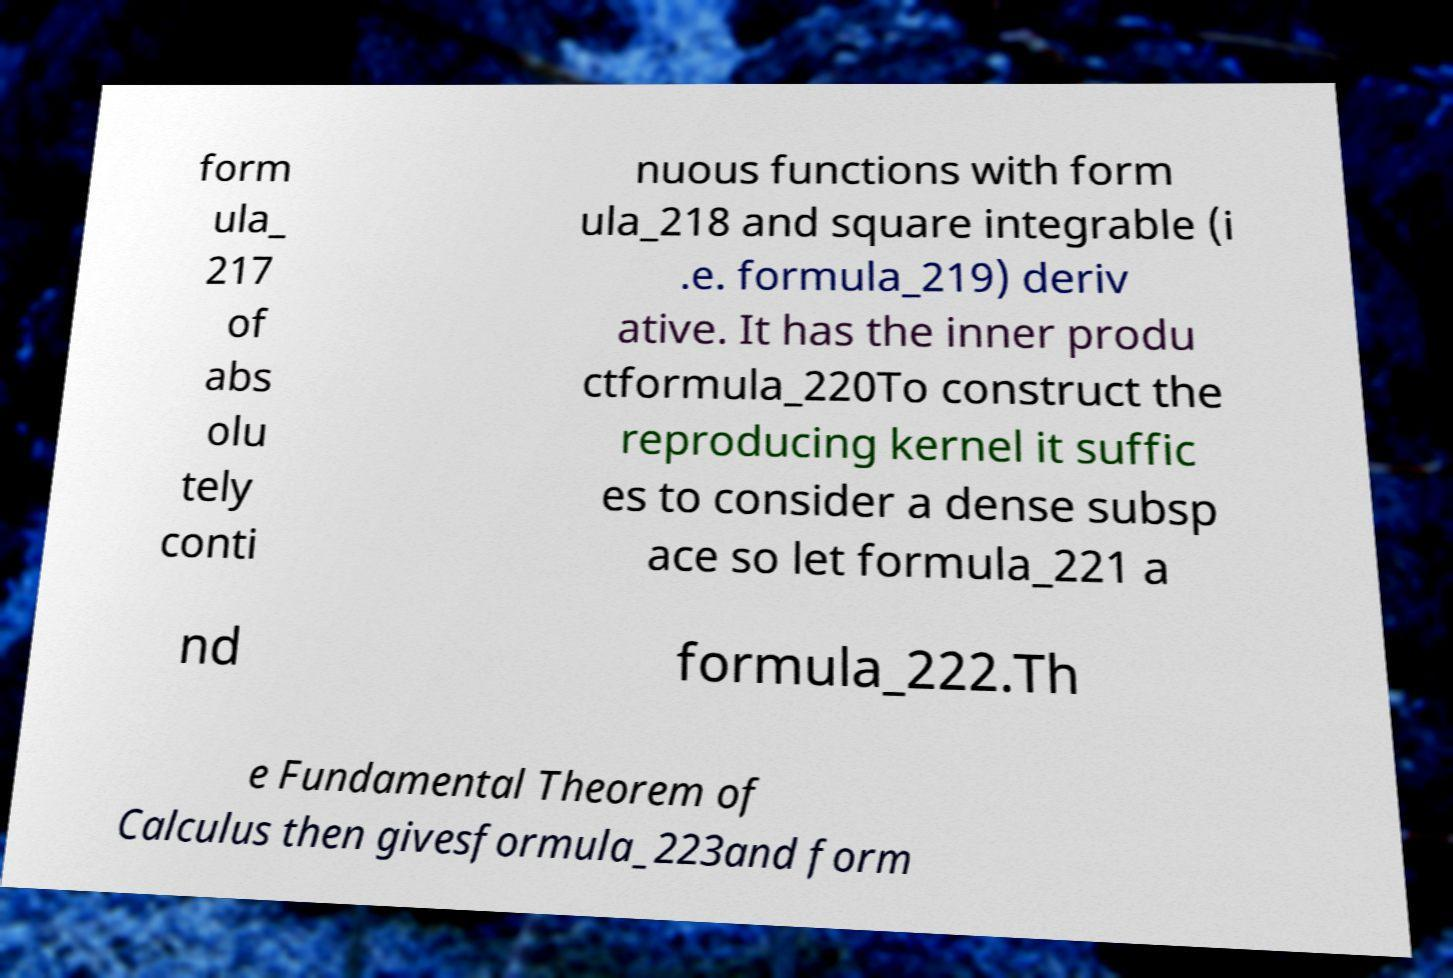Could you assist in decoding the text presented in this image and type it out clearly? form ula_ 217 of abs olu tely conti nuous functions with form ula_218 and square integrable (i .e. formula_219) deriv ative. It has the inner produ ctformula_220To construct the reproducing kernel it suffic es to consider a dense subsp ace so let formula_221 a nd formula_222.Th e Fundamental Theorem of Calculus then givesformula_223and form 